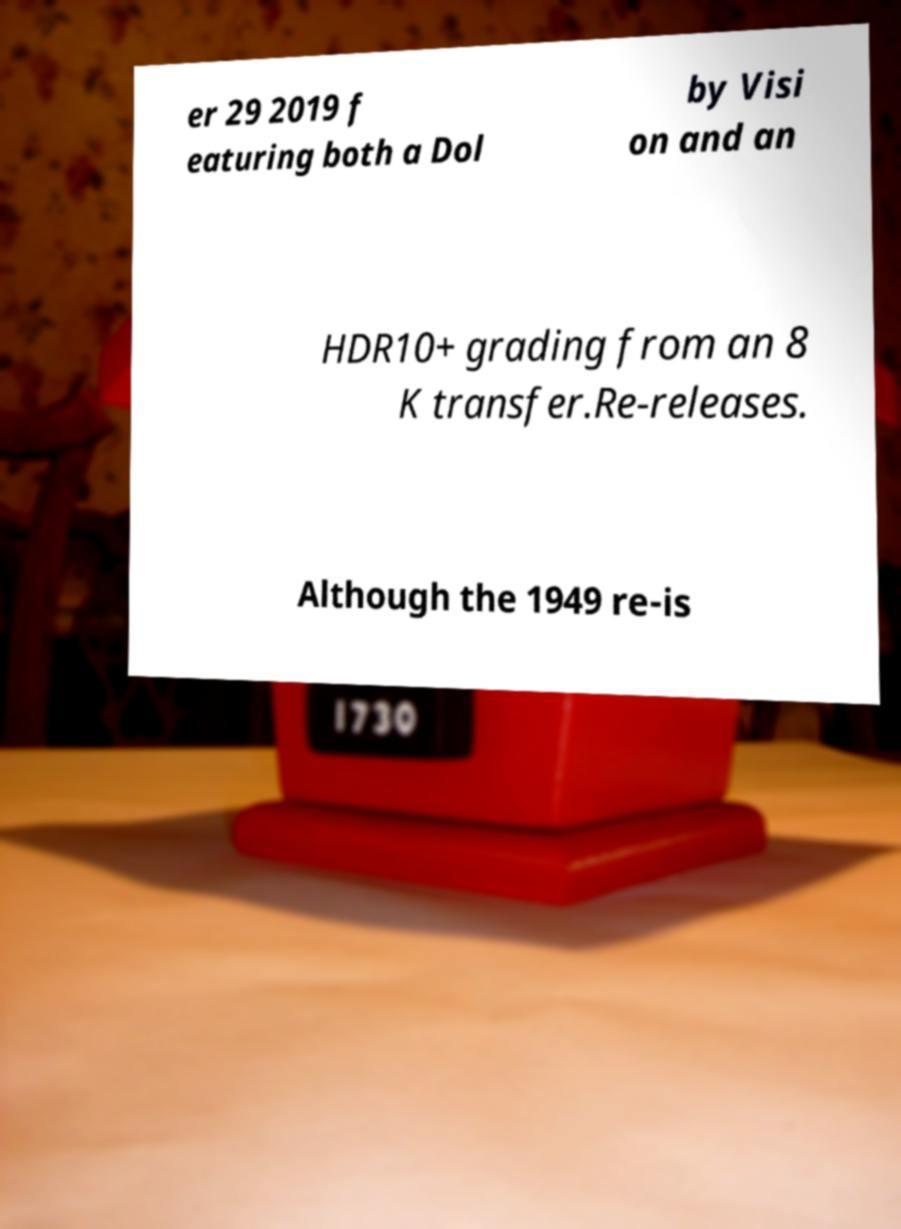Please read and relay the text visible in this image. What does it say? er 29 2019 f eaturing both a Dol by Visi on and an HDR10+ grading from an 8 K transfer.Re-releases. Although the 1949 re-is 